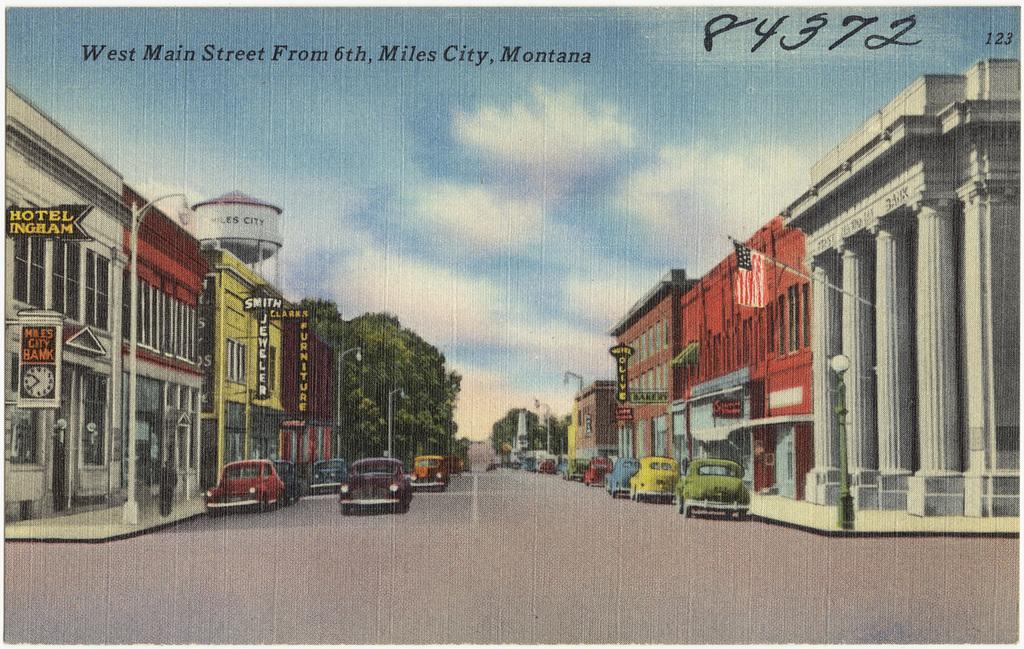What is featured on the poster in the image? The poster contains images of buildings and houses. What is associated with the buildings and houses in the image? There are boards associated with the buildings and houses. What type of vehicles can be seen in the image? There are cars visible in the image. What type of vegetation is present in the image? There are trees in the image. What type of structures are present in the image? There are poles in the image. What type of coat is the father wearing in the image? There is no father or coat present in the image. 